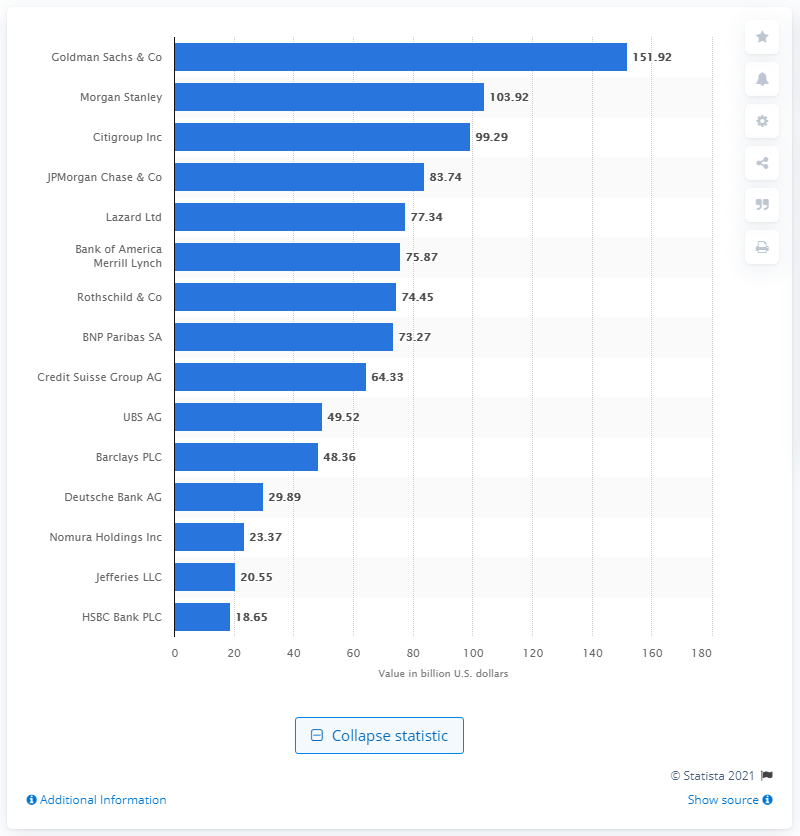Identify some key points in this picture. In 2019, the total value of Goldman Sachs' managed managed M&A transactions was $151.92 billion in dollars. 